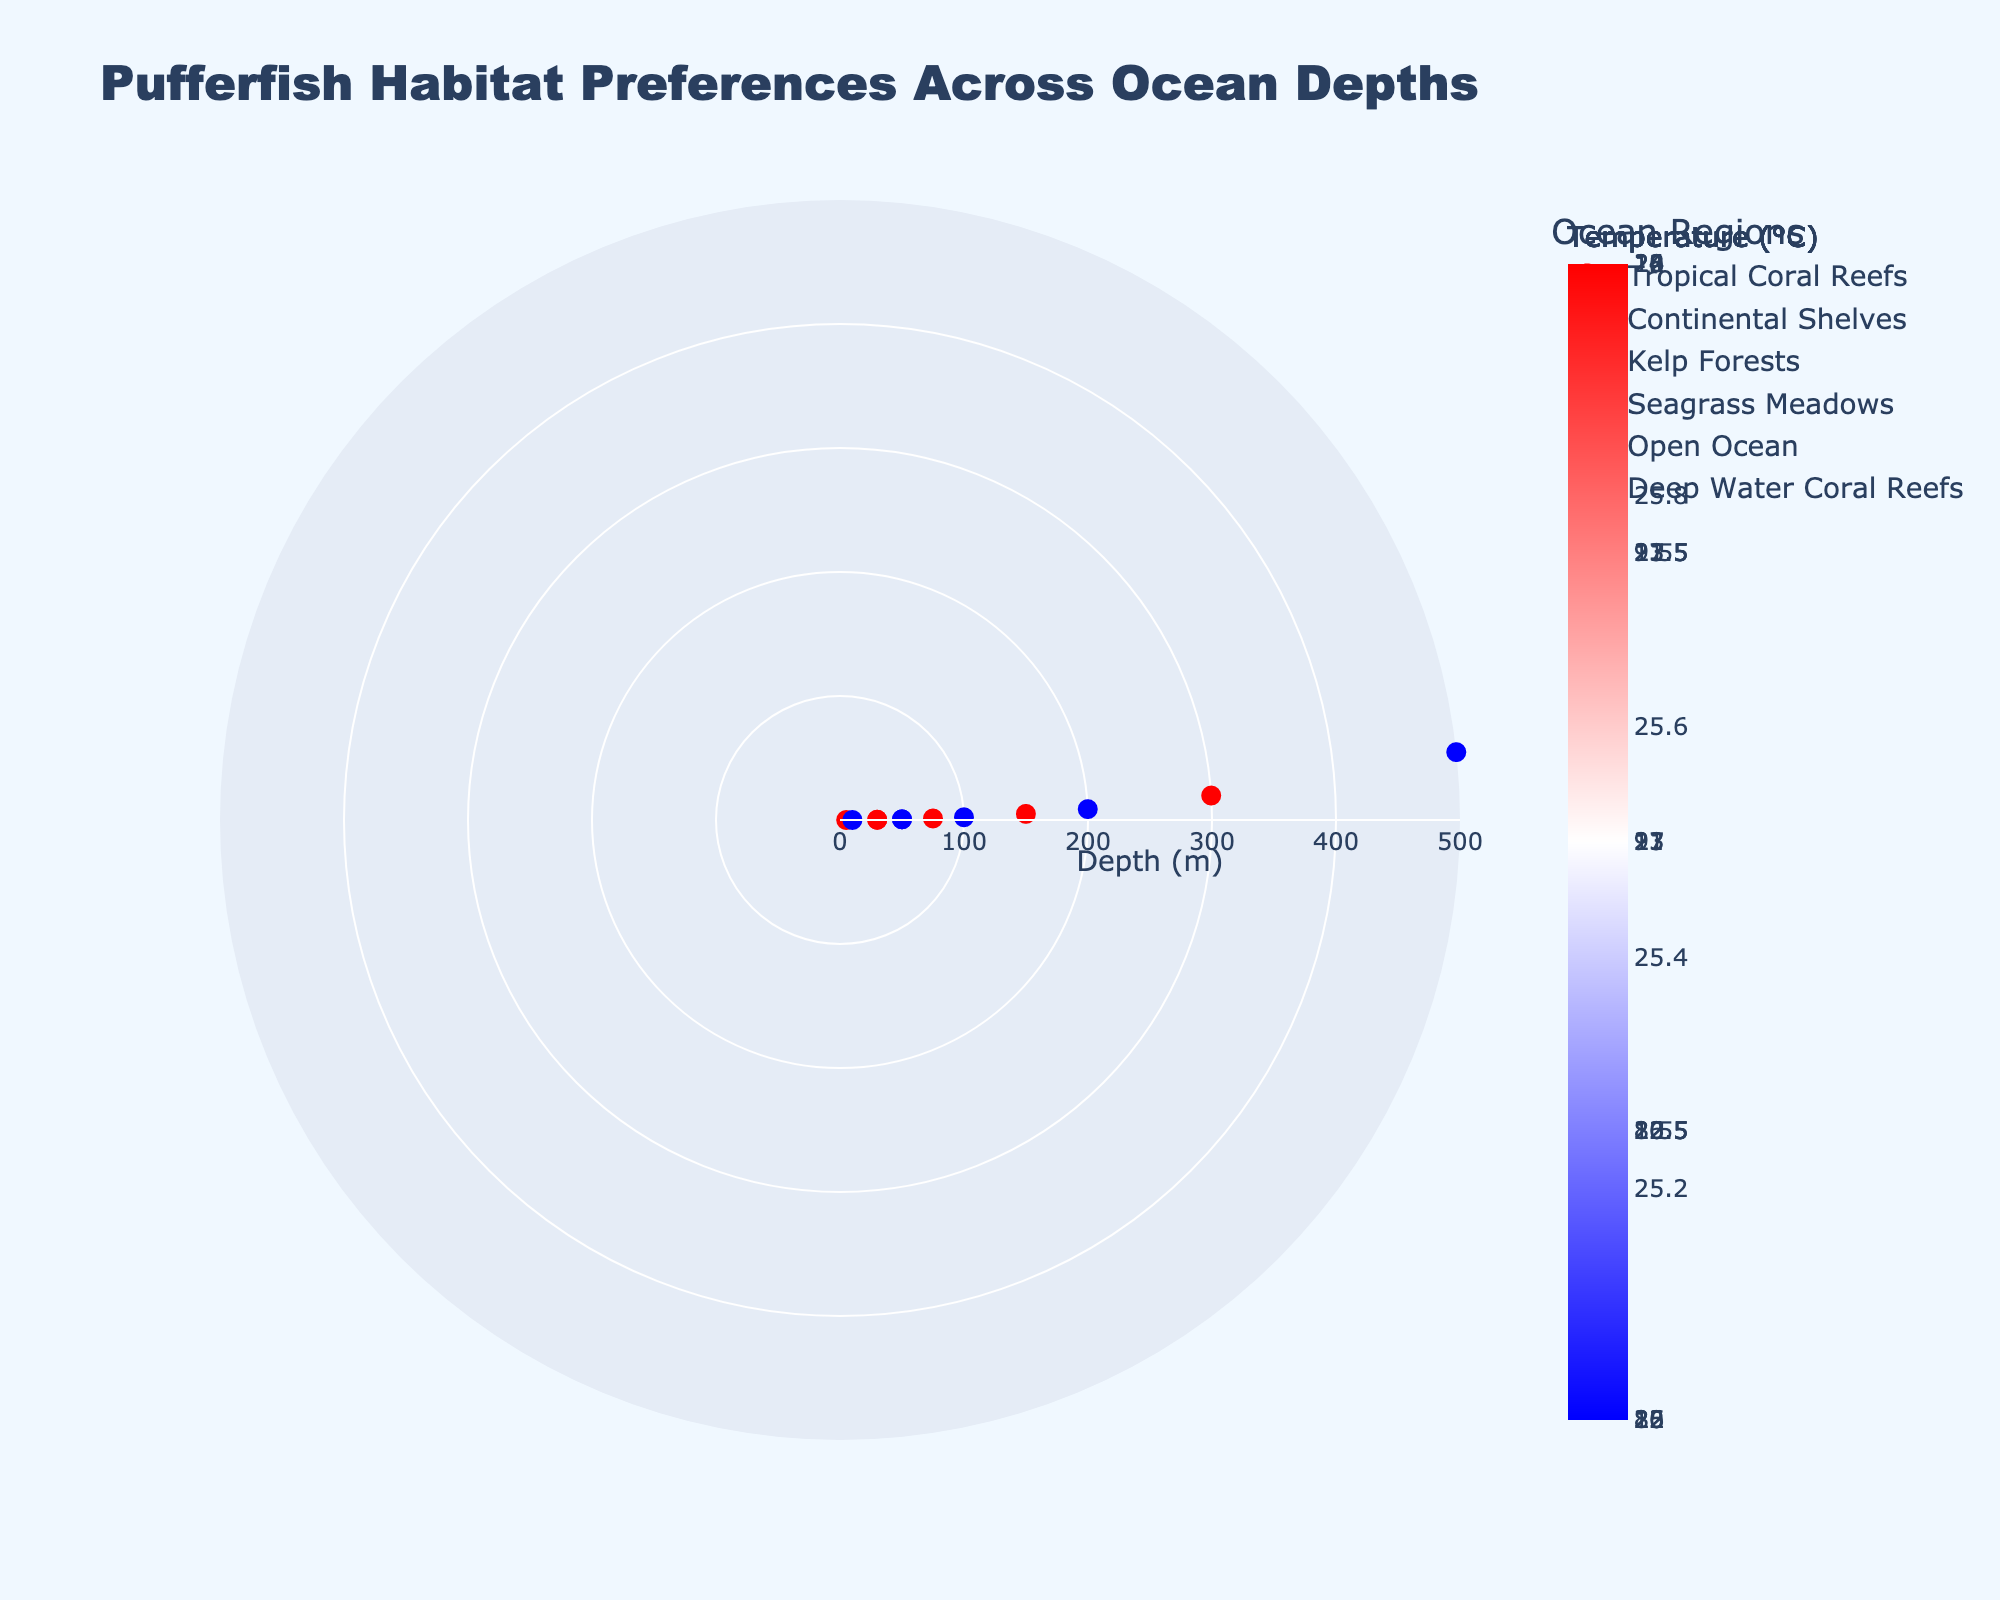What's the title of the figure? The title is displayed at the top of the figure and describes the content.
Answer: Pufferfish Habitat Preferences Across Ocean Depths How many ocean regions are shown in the figure? Each unique color and label in the legend represent a distinct ocean region.
Answer: Six What is the deepest depth represented on the plot? The radial axis shows the depth in meters, and the maximum value on this axis indicates the deepest depth.
Answer: 500 meters Which ocean region has data points at the greatest depths? By observing the furthest data points from the center of the plot, you can identify which ocean regions they belong to based on the colors and the legend.
Answer: Deep Water Coral Reefs What is the range of temperatures represented in the Tropical Coral Reefs region? Look at the color of the markers in the Tropical Coral Reefs region and reference the color scale to determine the temperature range.
Answer: 25-26°C Are there any ocean regions that have the same depth but different pH values? Compare data points at the same depth across different ocean regions, and check their hover text for pH values.
Answer: Yes Which ocean region has the highest pH value? Check the text in the hover information that indicates the pH value and find the maximum.
Answer: Tropical Coral Reefs How does the temperature vary with depth in the Open Ocean region? Observe the color gradient of the markers in the Open Ocean region, referencing the color scale to understand the temperature changes with depth.
Answer: Decreases What is the median depth of data points in the Seagrass Meadows region? List the depths of the data points in Seagrass Meadows, order them, and find the middle value.
Answer: 40 meters 